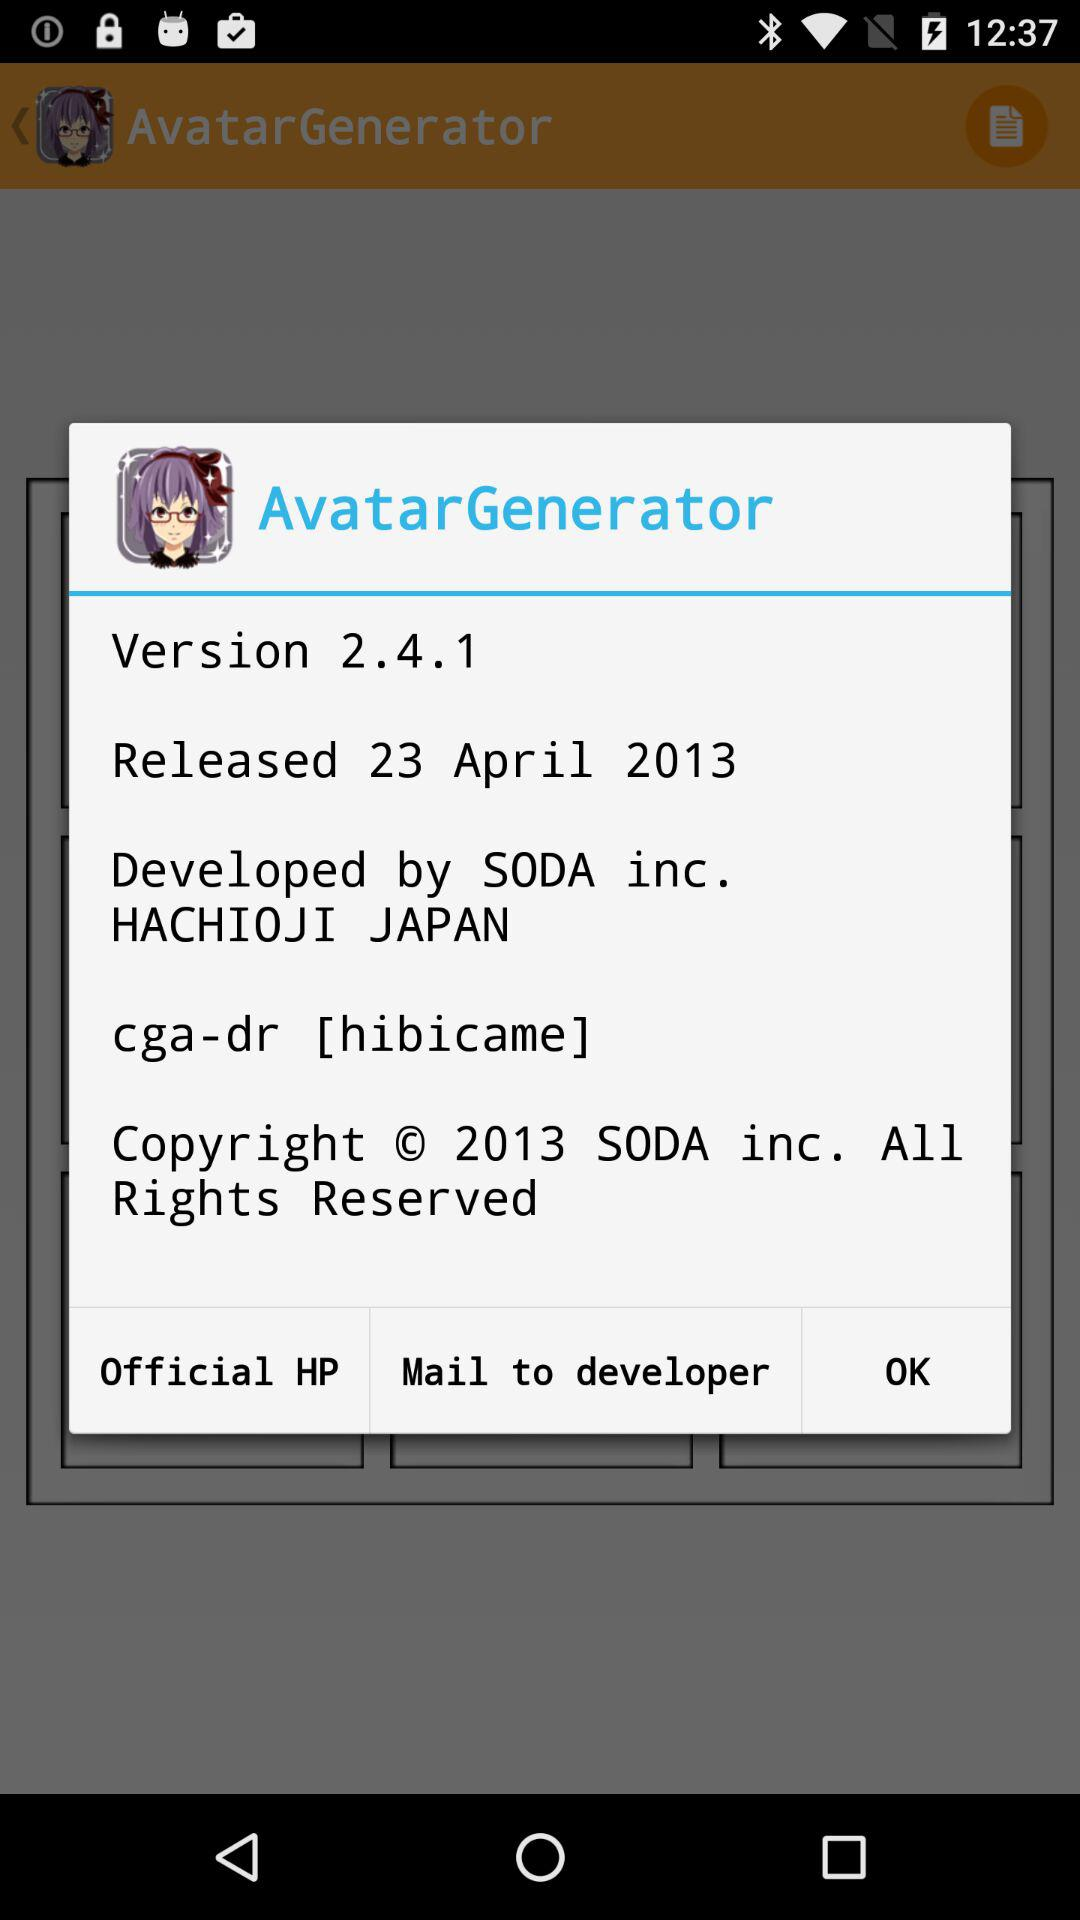What is the version? The version is 2.4.1. 